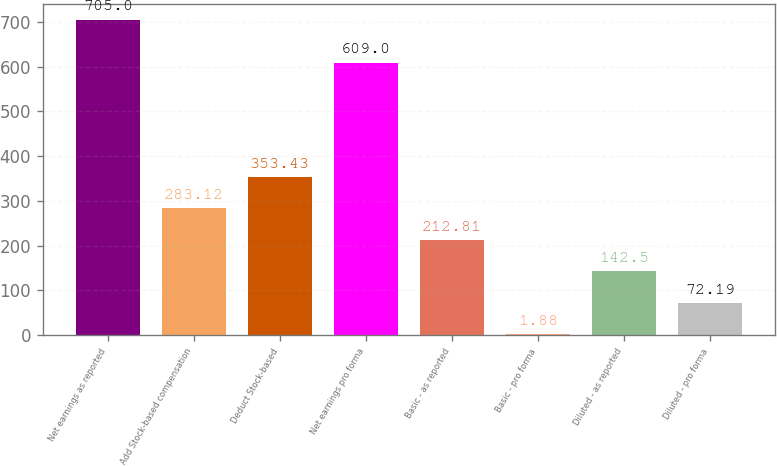Convert chart to OTSL. <chart><loc_0><loc_0><loc_500><loc_500><bar_chart><fcel>Net earnings as reported<fcel>Add Stock-based compensation<fcel>Deduct Stock-based<fcel>Net earnings pro forma<fcel>Basic - as reported<fcel>Basic - pro forma<fcel>Diluted - as reported<fcel>Diluted - pro forma<nl><fcel>705<fcel>283.12<fcel>353.43<fcel>609<fcel>212.81<fcel>1.88<fcel>142.5<fcel>72.19<nl></chart> 